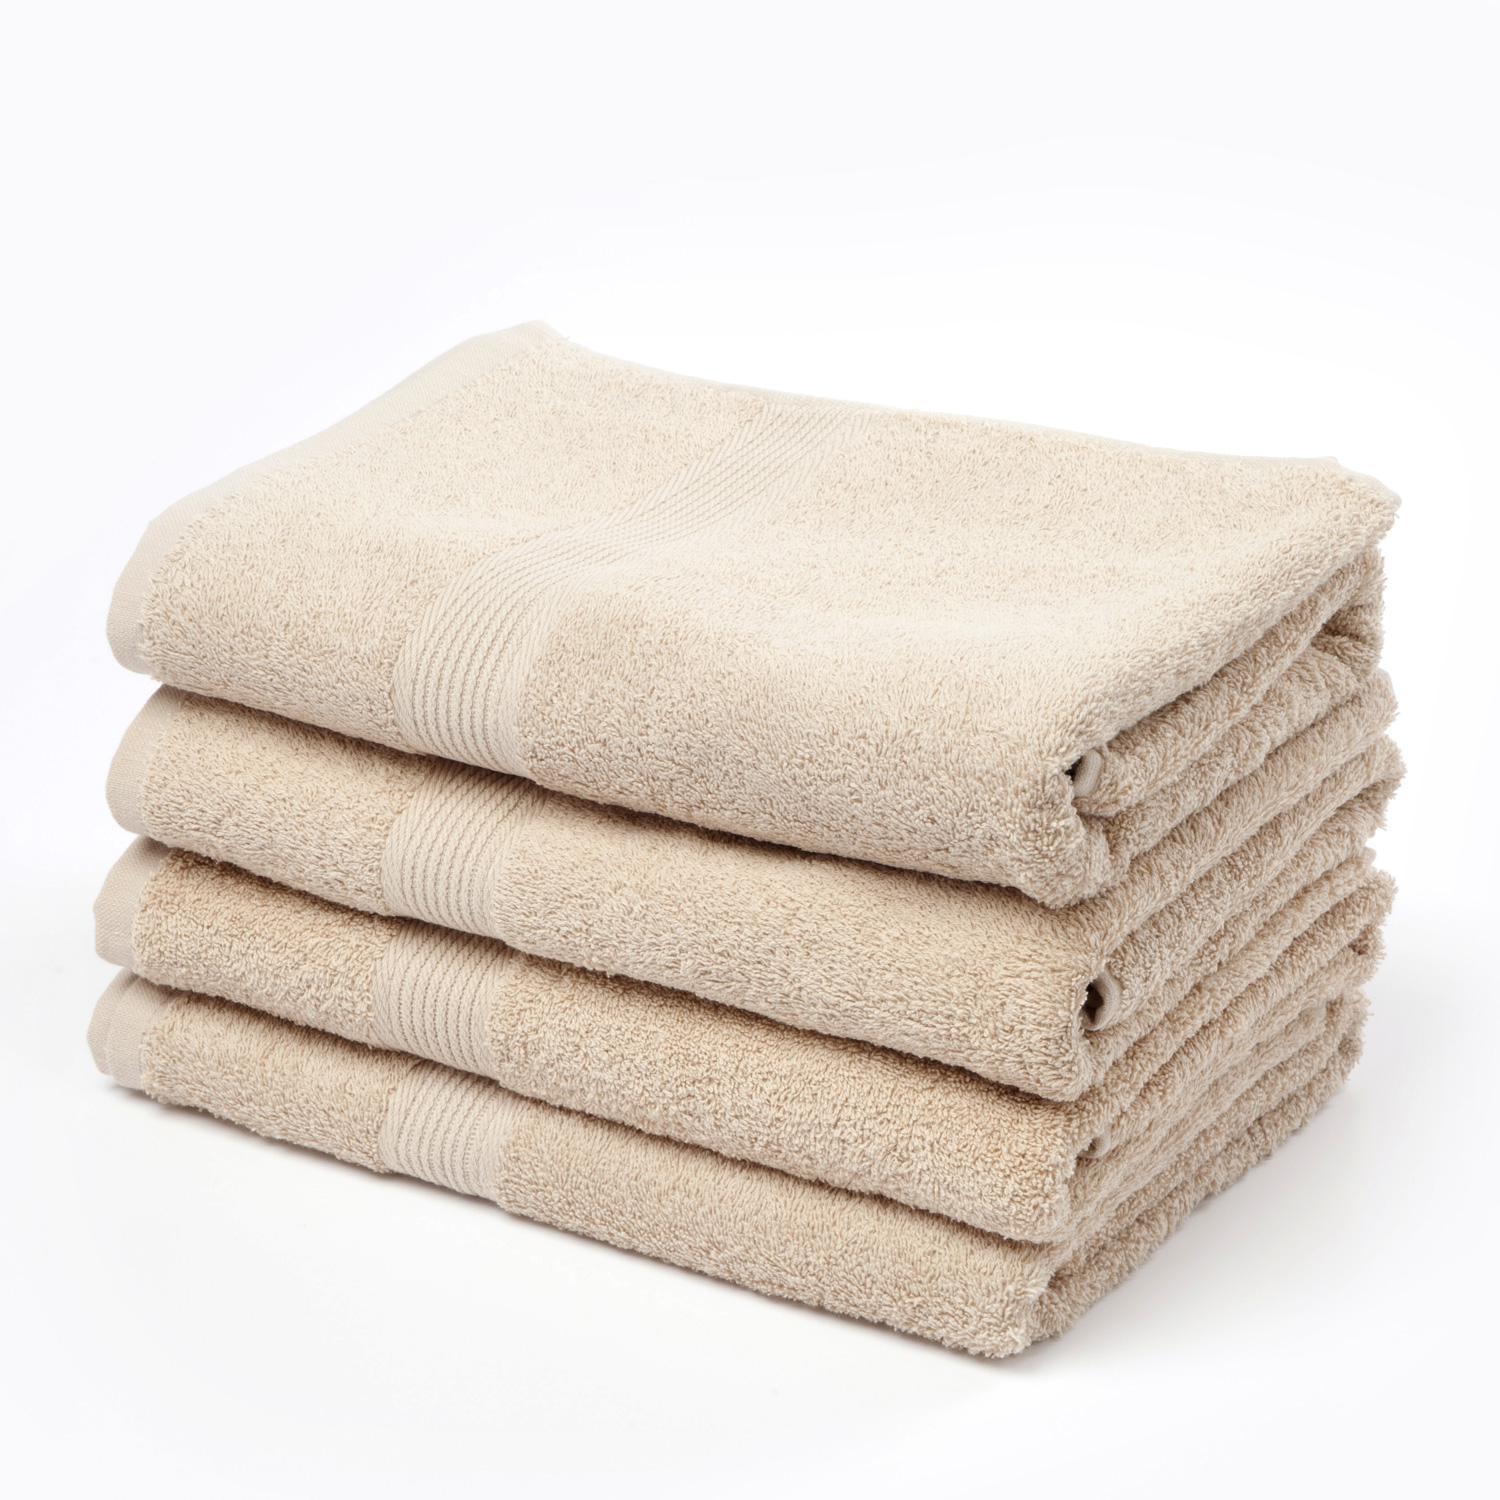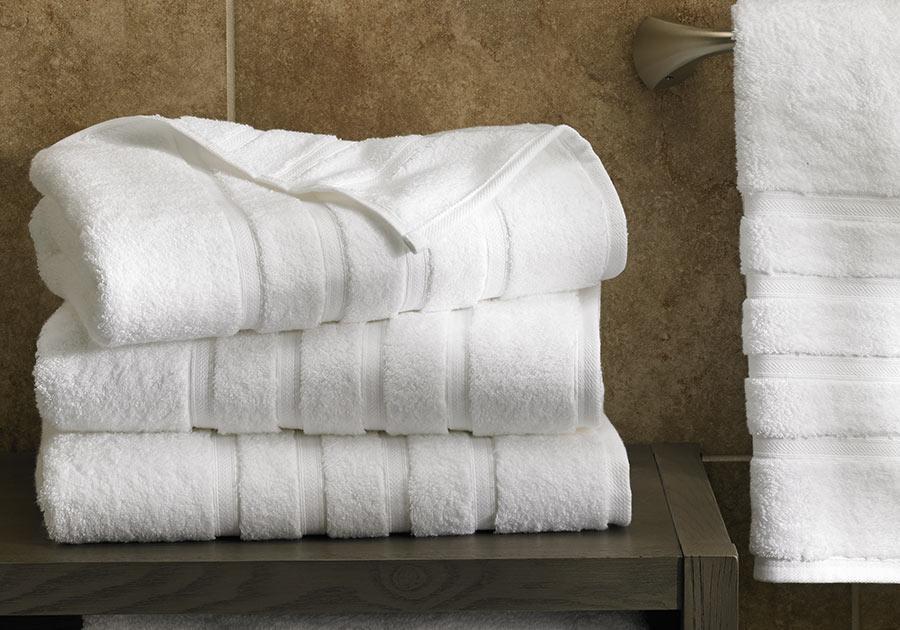The first image is the image on the left, the second image is the image on the right. Given the left and right images, does the statement "There is a stack of three white towels in one of the images." hold true? Answer yes or no. Yes. The first image is the image on the left, the second image is the image on the right. Examine the images to the left and right. Is the description "In each image there are more than two stacked towels" accurate? Answer yes or no. Yes. 